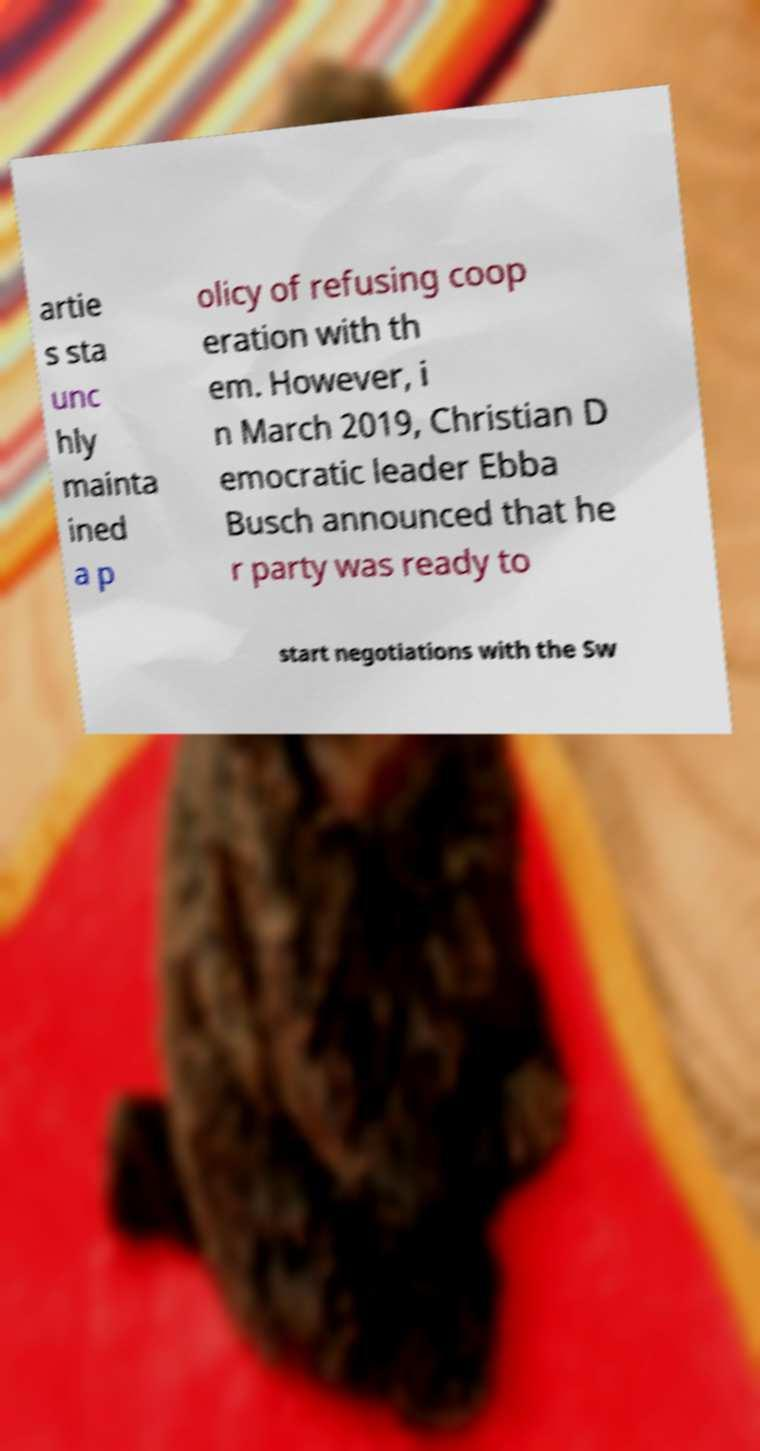I need the written content from this picture converted into text. Can you do that? artie s sta unc hly mainta ined a p olicy of refusing coop eration with th em. However, i n March 2019, Christian D emocratic leader Ebba Busch announced that he r party was ready to start negotiations with the Sw 